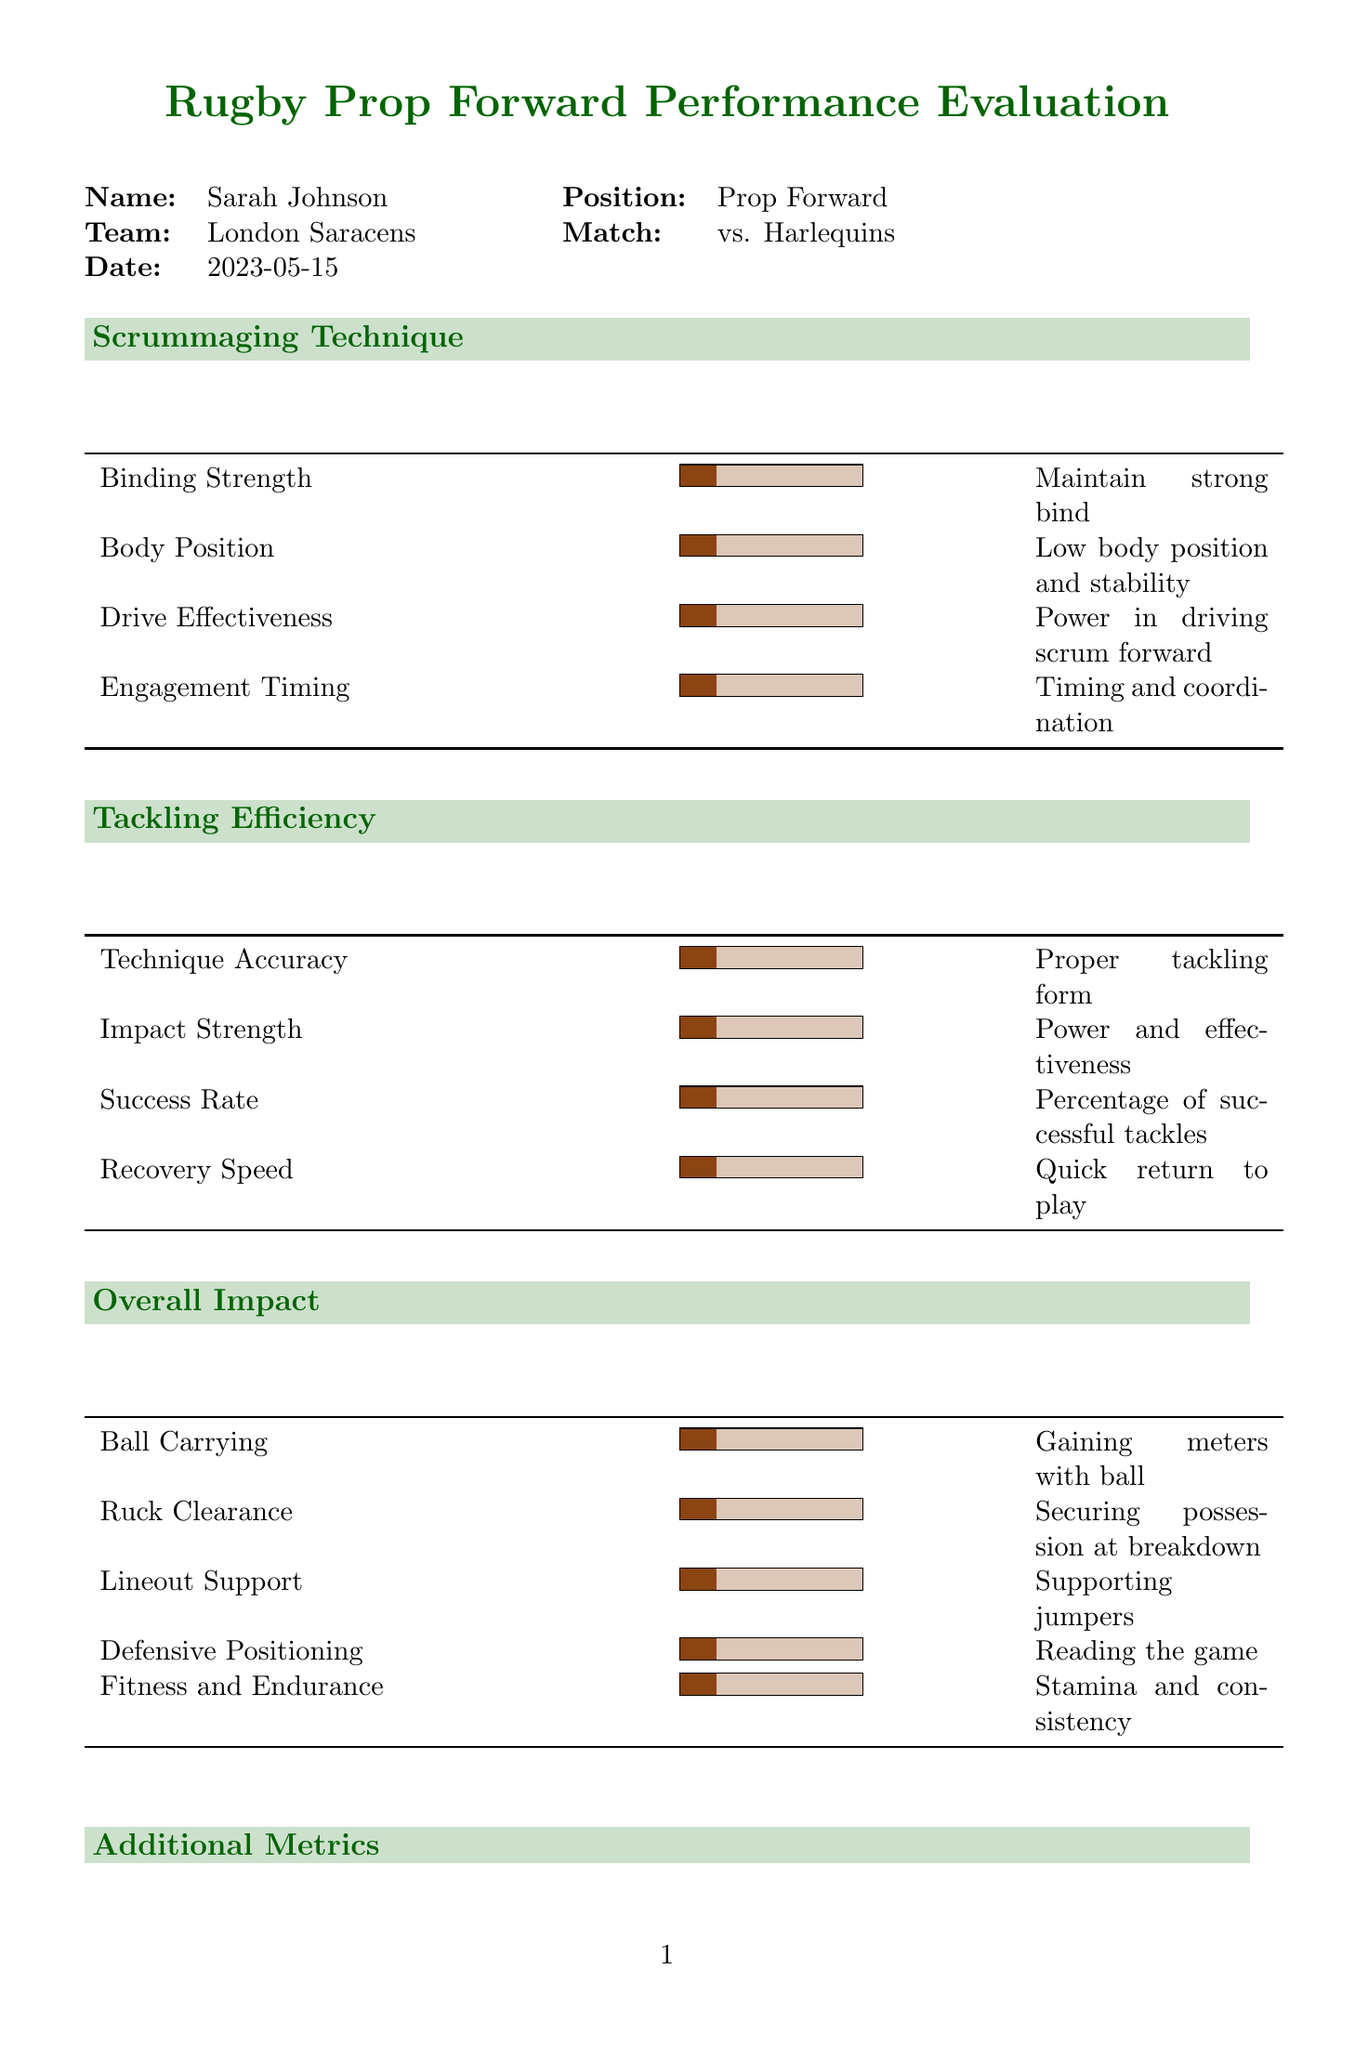What is the player's name? The document provides specific player information including the name, which is Sarah Johnson.
Answer: Sarah Johnson What is the match date? The date of the match is explicitly stated in the document as May 15, 2023.
Answer: 2023-05-15 How many scrums did Sarah participate in? The total number of scrums is noted in the additional metrics section as '0'.
Answer: 0 What is the rating for body position in scrummaging technique? The rating for body position is listed in the scrummaging technique section with a value of '1'.
Answer: 1 What was noted as an area for improvement? The document includes a section for identifying aspects of performance to improve but does not specify any; it simply states "Identify aspects of the game where the player can enhance their performance".
Answer: Identify aspects of the game where the player can enhance their performance What is the overall performance rating given? The overall performance rating section indicates a score of '1' out of 10.
Answer: 1 What is the player's team name? The document includes the player's team name which is mentioned as London Saracens.
Answer: London Saracens How many tackles did Sarah make during the match? The total number of tackles made is recorded as '0' in the additional metrics.
Answer: 0 What is the comment on binding strength in scrummaging? The document contains a comment for binding strength which is "Evaluate the player's ability to maintain a strong bind with teammates".
Answer: Evaluate the player's ability to maintain a strong bind with teammates 